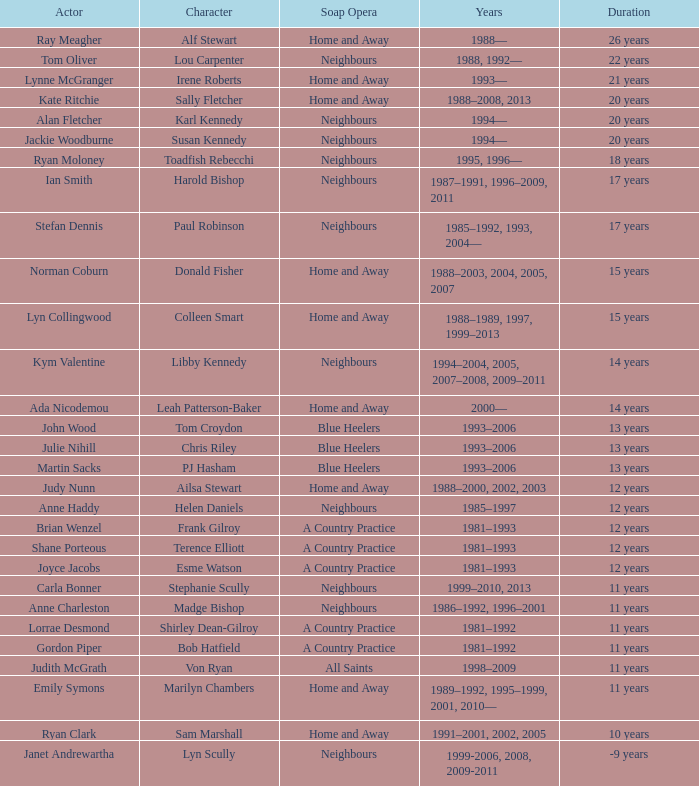Which actor played Harold Bishop for 17 years? Ian Smith. 